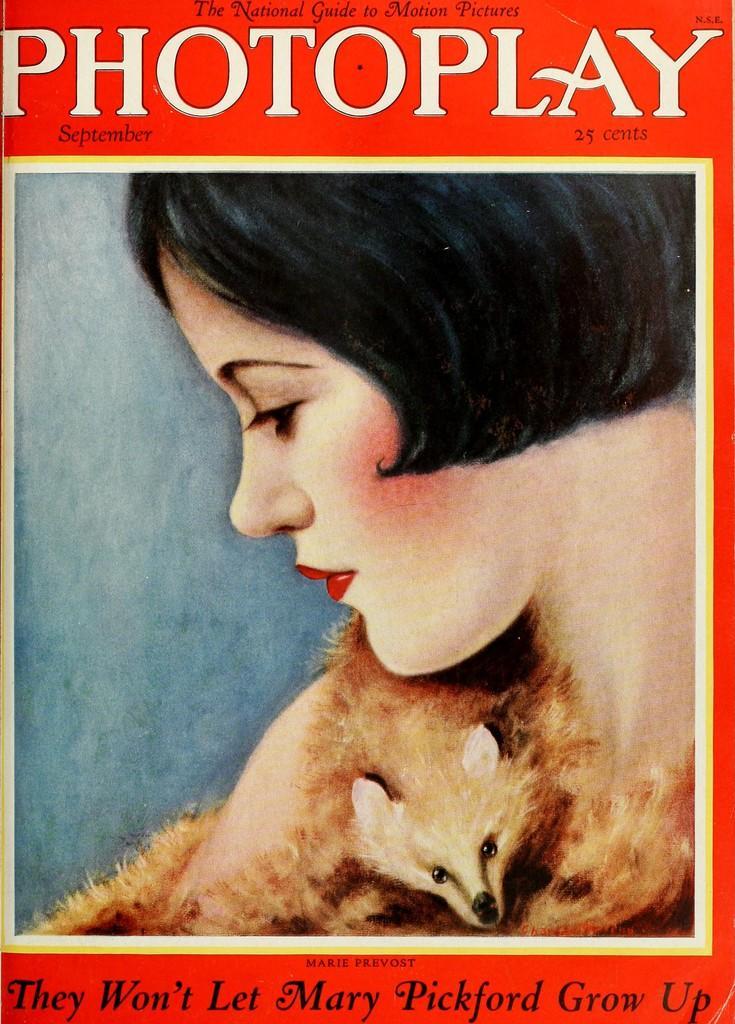Could you give a brief overview of what you see in this image? In this image I can see depiction picture of a woman and of an animal. I can also see something is written on the top and on the bottom side of this image. 